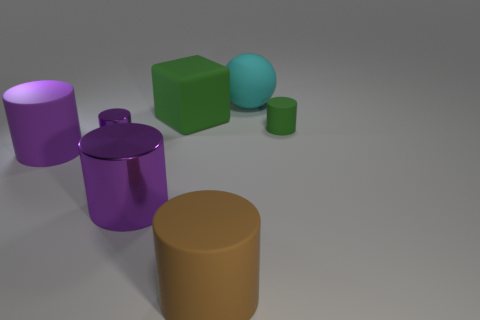Can you tell me the color of the cylindrical objects in the image? Certainly! There are two cylindrical objects in the image; one is purple and the other one is gold. Do these objects have any reflections or shadows? Yes, both cylindrical objects display subtle shadows on the ground, indicating a light source above them. There are also faint reflections on the purple cylinder's surface. 